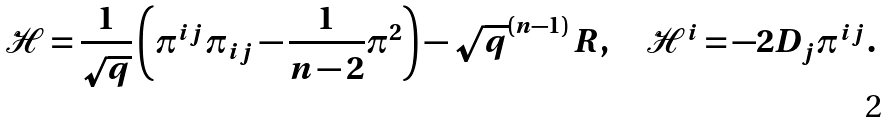Convert formula to latex. <formula><loc_0><loc_0><loc_500><loc_500>\mathcal { H } = \frac { 1 } { \sqrt { q } } \left ( \pi ^ { i j } \pi _ { i j } - \frac { 1 } { n - 2 } \pi ^ { 2 } \right ) - \sqrt { q } ^ { ( n - 1 ) } \, R , \quad \mathcal { H } ^ { i } = - 2 D _ { j } \pi ^ { i j } .</formula> 